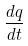<formula> <loc_0><loc_0><loc_500><loc_500>\frac { d q } { d t }</formula> 